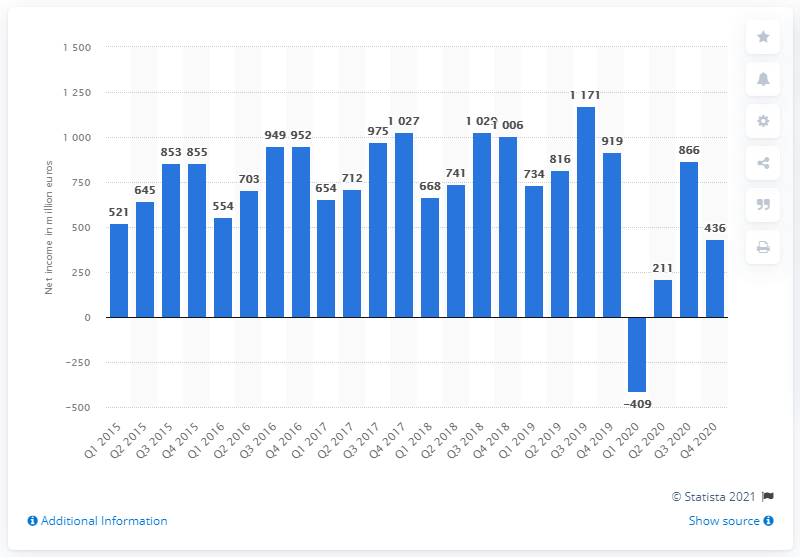Draw attention to some important aspects in this diagram. Inditex Group's net income in the third quarter of 2019 was €1,171 million. 